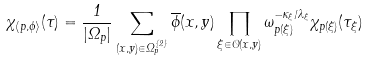Convert formula to latex. <formula><loc_0><loc_0><loc_500><loc_500>\chi _ { \left \langle p , \phi \right \rangle } ( \tau ) = \frac { 1 } { | \Omega _ { p } | } \sum _ { ( x , y ) \in \Omega _ { p } ^ { \left \{ 2 \right \} } } \overline { \phi } ( x , y ) \prod _ { \xi \in \mathcal { O } ( x , y ) } \omega _ { p ( \xi ) } ^ { - \kappa _ { \xi } / \lambda _ { \xi } } \chi _ { p ( \xi ) } ( \tau _ { \xi } )</formula> 